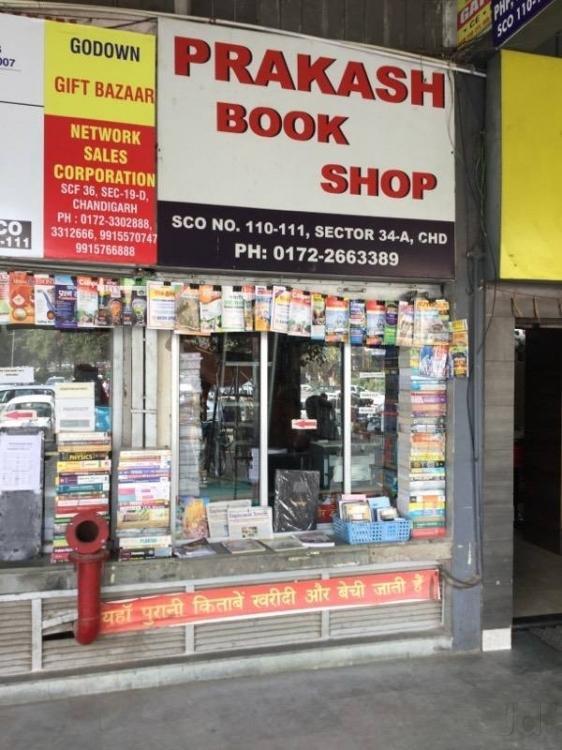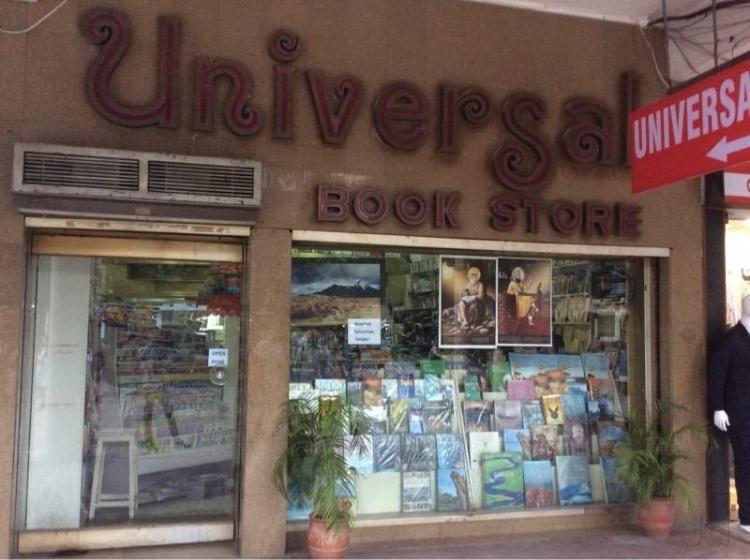The first image is the image on the left, the second image is the image on the right. Assess this claim about the two images: "In one of the images a person is standing by books with no outside signage.". Correct or not? Answer yes or no. No. 